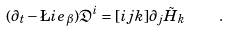Convert formula to latex. <formula><loc_0><loc_0><loc_500><loc_500>( \partial _ { t } - \L i e _ { \beta } ) \mathfrak { D } ^ { i } = [ i j k ] \partial _ { j } \tilde { H } _ { k } \quad .</formula> 